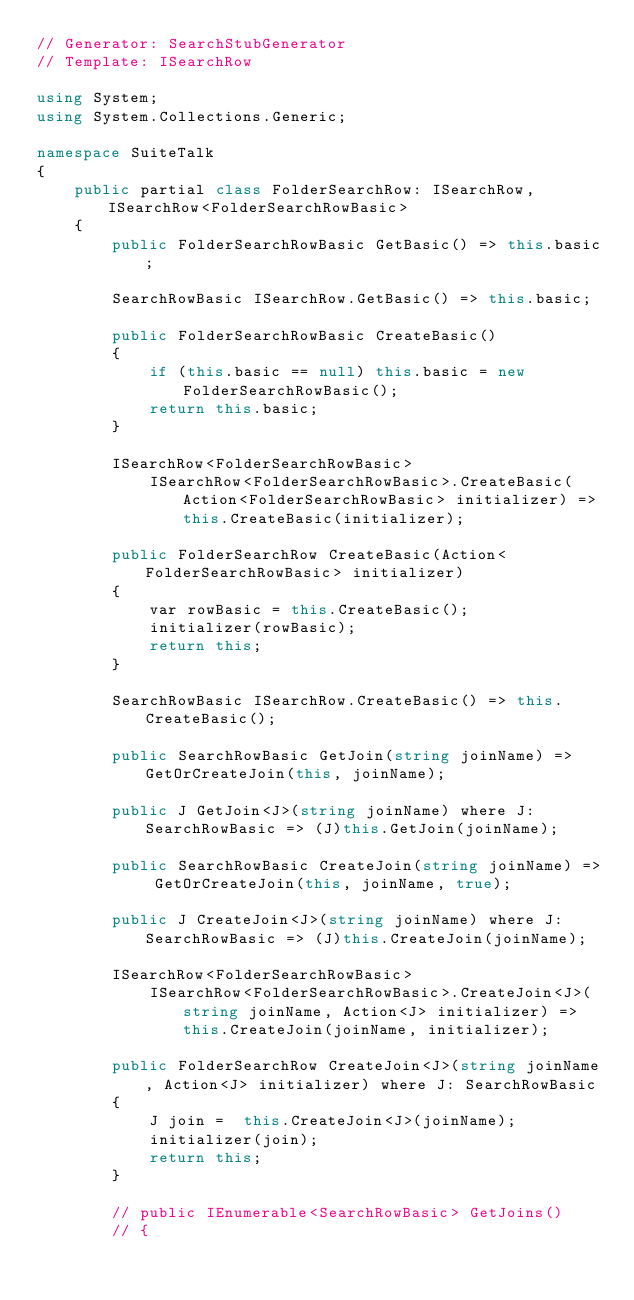Convert code to text. <code><loc_0><loc_0><loc_500><loc_500><_C#_>// Generator: SearchStubGenerator
// Template: ISearchRow

using System;
using System.Collections.Generic;

namespace SuiteTalk
{
    public partial class FolderSearchRow: ISearchRow, ISearchRow<FolderSearchRowBasic>
    {
        public FolderSearchRowBasic GetBasic() => this.basic;

        SearchRowBasic ISearchRow.GetBasic() => this.basic;

        public FolderSearchRowBasic CreateBasic()
        {
            if (this.basic == null) this.basic = new FolderSearchRowBasic();
            return this.basic;
        }

        ISearchRow<FolderSearchRowBasic> 
            ISearchRow<FolderSearchRowBasic>.CreateBasic(Action<FolderSearchRowBasic> initializer) => this.CreateBasic(initializer);

        public FolderSearchRow CreateBasic(Action<FolderSearchRowBasic> initializer)
        {
            var rowBasic = this.CreateBasic();
            initializer(rowBasic);
            return this;
        }

        SearchRowBasic ISearchRow.CreateBasic() => this.CreateBasic();

        public SearchRowBasic GetJoin(string joinName) => GetOrCreateJoin(this, joinName);

        public J GetJoin<J>(string joinName) where J: SearchRowBasic => (J)this.GetJoin(joinName);

        public SearchRowBasic CreateJoin(string joinName) => GetOrCreateJoin(this, joinName, true);

        public J CreateJoin<J>(string joinName) where J: SearchRowBasic => (J)this.CreateJoin(joinName);

        ISearchRow<FolderSearchRowBasic> 
            ISearchRow<FolderSearchRowBasic>.CreateJoin<J>(string joinName, Action<J> initializer) => this.CreateJoin(joinName, initializer);

        public FolderSearchRow CreateJoin<J>(string joinName, Action<J> initializer) where J: SearchRowBasic
        {
            J join =  this.CreateJoin<J>(joinName);
            initializer(join);
            return this;
        }

        // public IEnumerable<SearchRowBasic> GetJoins()
        // {</code> 